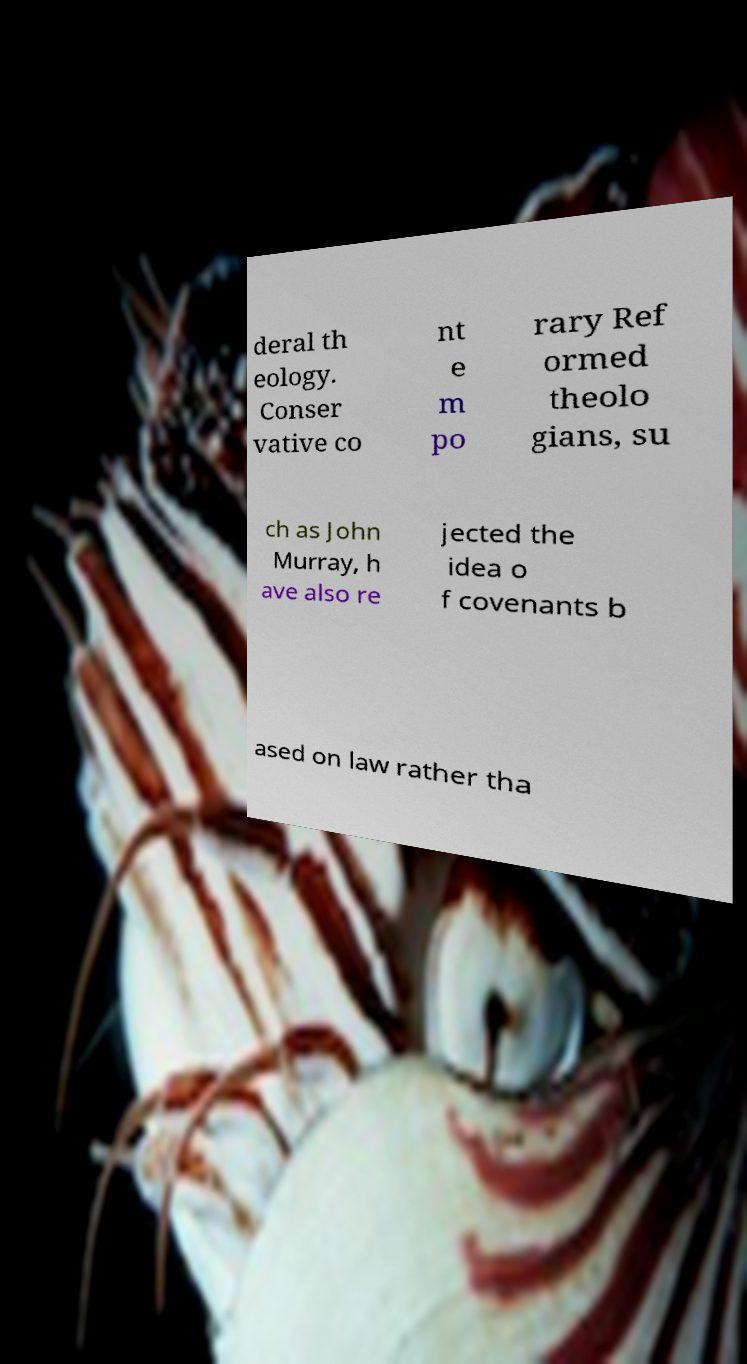There's text embedded in this image that I need extracted. Can you transcribe it verbatim? deral th eology. Conser vative co nt e m po rary Ref ormed theolo gians, su ch as John Murray, h ave also re jected the idea o f covenants b ased on law rather tha 